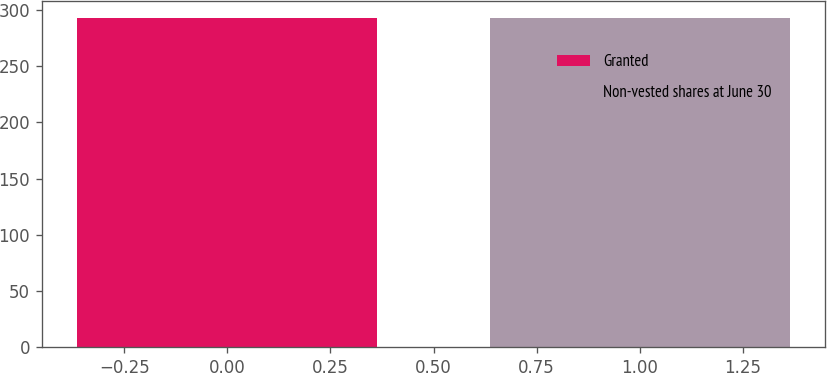Convert chart to OTSL. <chart><loc_0><loc_0><loc_500><loc_500><bar_chart><fcel>Granted<fcel>Non-vested shares at June 30<nl><fcel>293<fcel>293.1<nl></chart> 